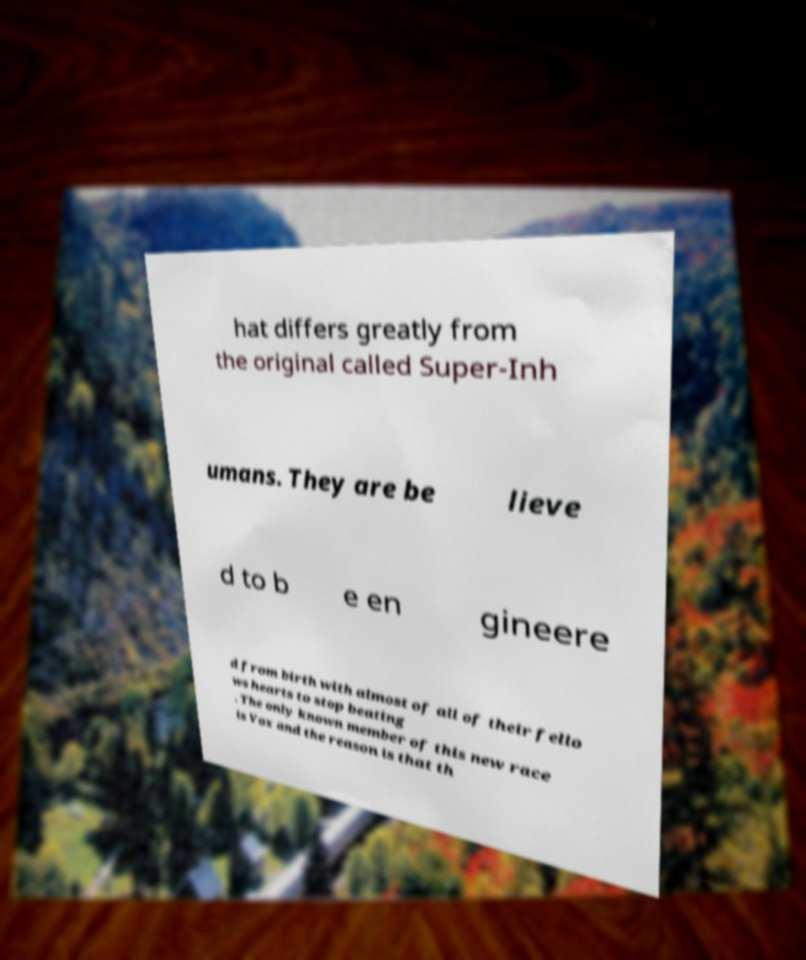I need the written content from this picture converted into text. Can you do that? hat differs greatly from the original called Super-Inh umans. They are be lieve d to b e en gineere d from birth with almost of all of their fello ws hearts to stop beating . The only known member of this new race is Vox and the reason is that th 